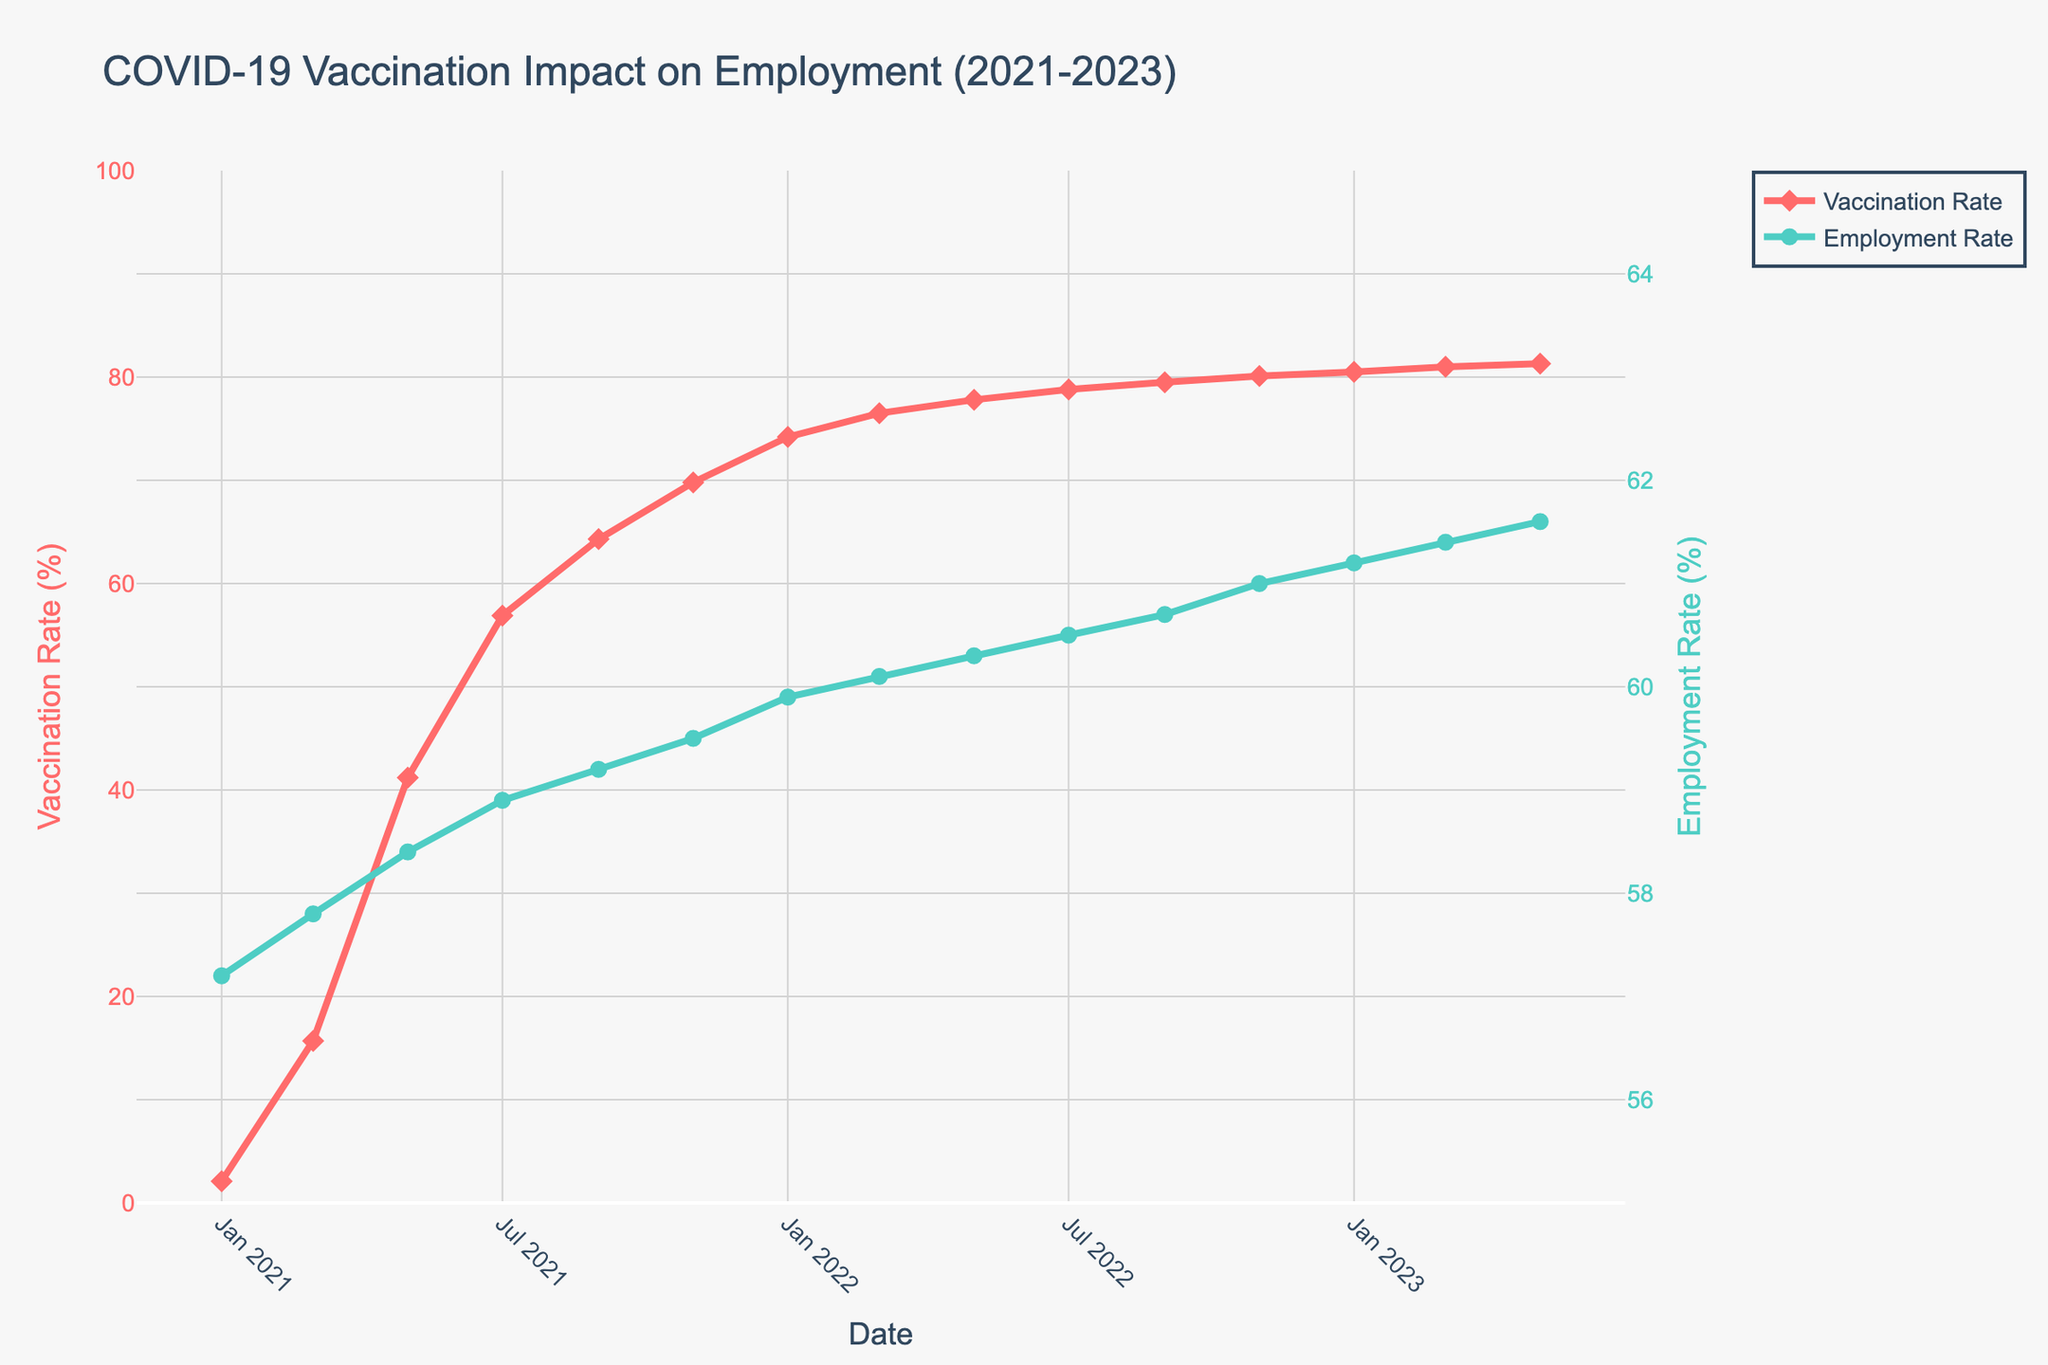What is the trend in vaccination rates from the start of 2021 to mid-2023? By examining the line representing vaccination rates, it is apparent that there is a consistent upward trend from January 2021 to May 2023, indicating an increase in the percentage of vaccinated individuals over time.
Answer: Upward trend Compare the employment rate in January 2021 and January 2023. The employment rate in January 2021 is 57.2%, while in January 2023, it is 61.2%. Therefore, the employment rate increased over these two years.
Answer: Increased What is the difference in vaccination rates between July 2021 and July 2022? The vaccination rate in July 2021 is 56.9%, and in July 2022, it is 78.8%. The difference between these two percentages is 78.8% - 56.9% = 21.9%.
Answer: 21.9% Is there a point in time when the employment rate remains constant for two consecutive months? If so, when? By closely examining the line representing the employment rate, it remains constant from March 2022 to May 2022, where the rate is 60.1%.
Answer: March 2022 to May 2022 Which had a higher growth rate from January 2021 to January 2022: vaccination rate or employment rate? The vaccination rate grew from 2.1% to 74.2%, an increase of 72.1 percentage points. The employment rate grew from 57.2% to 59.9%, an increase of 2.7 percentage points. The vaccination rate had a higher growth rate.
Answer: Vaccination rate What is the average employment rate over the entire period from January 2021 to May 2023? Sum of employment rates: 57.2 + 57.8 + 58.4 + 58.9 + 59.2 + 59.5 + 59.9 + 60.1 + 60.3 + 60.5 + 60.7 + 61.0 + 61.2 + 61.4 + 61.6 = 897.7. Number of data points is 15. Hence, average employment rate = 897.7 / 15 = 59.85%.
Answer: 59.85% What is the employment rate when the vaccination rate hits approximately 80%? The vaccination rate hits 80% in November 2022 (80.1%). The corresponding employment rate is 61.0%.
Answer: 61.0% Compare the shapes and colors of the markers used in the chart. The markers for vaccination rates are diamond-shaped and red, while the markers for employment rates are circle-shaped and green.
Answer: Diamonds: vaccination, Circles: employment What month and year did the vaccination rate surpass 50%? Observing the graph, the vaccination rate surpasses 50% in May 2021 (41.2%) and continues to grow until it exceeds 50% by July 2021 with 56.9%.
Answer: July 2021 Is there a correlation between the vaccination rate and employment rate over the given period? From visual inspection, as the vaccination rate increased, the employment rate also showed an upward trend, suggesting a positive correlation.
Answer: Positive correlation 